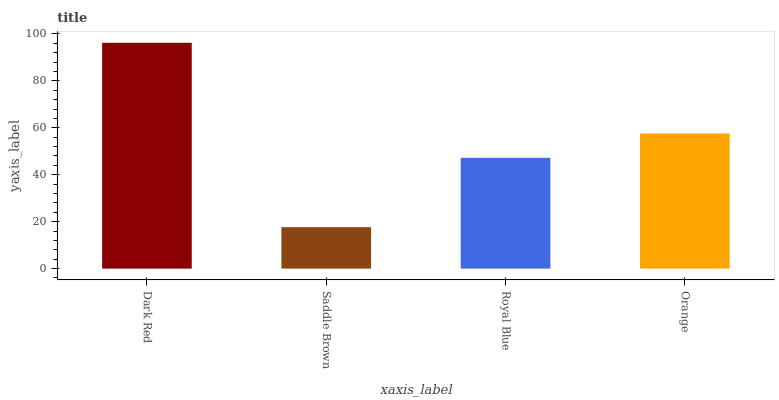Is Saddle Brown the minimum?
Answer yes or no. Yes. Is Dark Red the maximum?
Answer yes or no. Yes. Is Royal Blue the minimum?
Answer yes or no. No. Is Royal Blue the maximum?
Answer yes or no. No. Is Royal Blue greater than Saddle Brown?
Answer yes or no. Yes. Is Saddle Brown less than Royal Blue?
Answer yes or no. Yes. Is Saddle Brown greater than Royal Blue?
Answer yes or no. No. Is Royal Blue less than Saddle Brown?
Answer yes or no. No. Is Orange the high median?
Answer yes or no. Yes. Is Royal Blue the low median?
Answer yes or no. Yes. Is Royal Blue the high median?
Answer yes or no. No. Is Orange the low median?
Answer yes or no. No. 